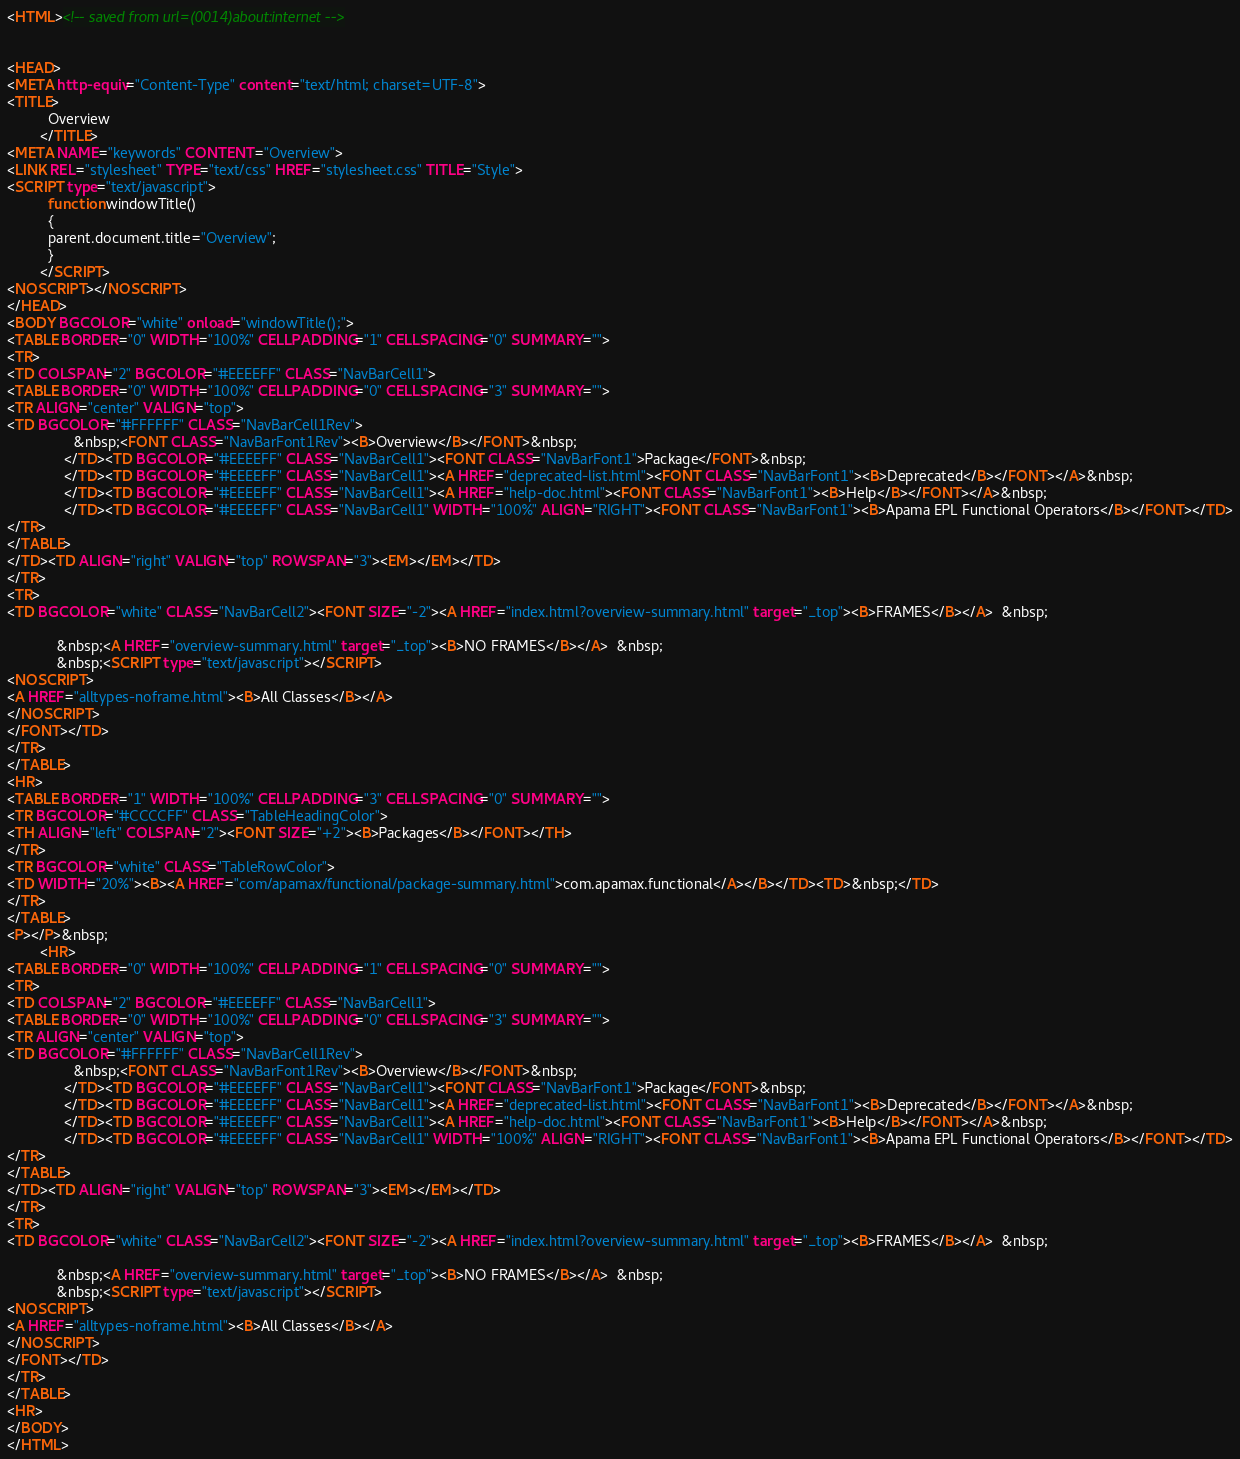Convert code to text. <code><loc_0><loc_0><loc_500><loc_500><_HTML_><HTML><!-- saved from url=(0014)about:internet -->


<HEAD>
<META http-equiv="Content-Type" content="text/html; charset=UTF-8">
<TITLE>
          Overview
        </TITLE>
<META NAME="keywords" CONTENT="Overview">
<LINK REL="stylesheet" TYPE="text/css" HREF="stylesheet.css" TITLE="Style">
<SCRIPT type="text/javascript">
          function windowTitle()
          {
          parent.document.title="Overview";
          }
        </SCRIPT>
<NOSCRIPT></NOSCRIPT>
</HEAD>
<BODY BGCOLOR="white" onload="windowTitle();">
<TABLE BORDER="0" WIDTH="100%" CELLPADDING="1" CELLSPACING="0" SUMMARY="">
<TR>
<TD COLSPAN="2" BGCOLOR="#EEEEFF" CLASS="NavBarCell1">
<TABLE BORDER="0" WIDTH="100%" CELLPADDING="0" CELLSPACING="3" SUMMARY="">
<TR ALIGN="center" VALIGN="top">
<TD BGCOLOR="#FFFFFF" CLASS="NavBarCell1Rev">
                &nbsp;<FONT CLASS="NavBarFont1Rev"><B>Overview</B></FONT>&nbsp;
              </TD><TD BGCOLOR="#EEEEFF" CLASS="NavBarCell1"><FONT CLASS="NavBarFont1">Package</FONT>&nbsp;
              </TD><TD BGCOLOR="#EEEEFF" CLASS="NavBarCell1"><A HREF="deprecated-list.html"><FONT CLASS="NavBarFont1"><B>Deprecated</B></FONT></A>&nbsp;
              </TD><TD BGCOLOR="#EEEEFF" CLASS="NavBarCell1"><A HREF="help-doc.html"><FONT CLASS="NavBarFont1"><B>Help</B></FONT></A>&nbsp;
              </TD><TD BGCOLOR="#EEEEFF" CLASS="NavBarCell1" WIDTH="100%" ALIGN="RIGHT"><FONT CLASS="NavBarFont1"><B>Apama EPL Functional Operators</B></FONT></TD>
</TR>
</TABLE>
</TD><TD ALIGN="right" VALIGN="top" ROWSPAN="3"><EM></EM></TD>
</TR>
<TR>
<TD BGCOLOR="white" CLASS="NavBarCell2"><FONT SIZE="-2"><A HREF="index.html?overview-summary.html" target="_top"><B>FRAMES</B></A>  &nbsp;

            &nbsp;<A HREF="overview-summary.html" target="_top"><B>NO FRAMES</B></A>  &nbsp;
            &nbsp;<SCRIPT type="text/javascript"></SCRIPT>
<NOSCRIPT>
<A HREF="alltypes-noframe.html"><B>All Classes</B></A>
</NOSCRIPT>
</FONT></TD>
</TR>
</TABLE>
<HR>
<TABLE BORDER="1" WIDTH="100%" CELLPADDING="3" CELLSPACING="0" SUMMARY="">
<TR BGCOLOR="#CCCCFF" CLASS="TableHeadingColor">
<TH ALIGN="left" COLSPAN="2"><FONT SIZE="+2"><B>Packages</B></FONT></TH>
</TR>
<TR BGCOLOR="white" CLASS="TableRowColor">
<TD WIDTH="20%"><B><A HREF="com/apamax/functional/package-summary.html">com.apamax.functional</A></B></TD><TD>&nbsp;</TD>
</TR>
</TABLE>
<P></P>&nbsp;
        <HR>
<TABLE BORDER="0" WIDTH="100%" CELLPADDING="1" CELLSPACING="0" SUMMARY="">
<TR>
<TD COLSPAN="2" BGCOLOR="#EEEEFF" CLASS="NavBarCell1">
<TABLE BORDER="0" WIDTH="100%" CELLPADDING="0" CELLSPACING="3" SUMMARY="">
<TR ALIGN="center" VALIGN="top">
<TD BGCOLOR="#FFFFFF" CLASS="NavBarCell1Rev">
                &nbsp;<FONT CLASS="NavBarFont1Rev"><B>Overview</B></FONT>&nbsp;
              </TD><TD BGCOLOR="#EEEEFF" CLASS="NavBarCell1"><FONT CLASS="NavBarFont1">Package</FONT>&nbsp;
              </TD><TD BGCOLOR="#EEEEFF" CLASS="NavBarCell1"><A HREF="deprecated-list.html"><FONT CLASS="NavBarFont1"><B>Deprecated</B></FONT></A>&nbsp;
              </TD><TD BGCOLOR="#EEEEFF" CLASS="NavBarCell1"><A HREF="help-doc.html"><FONT CLASS="NavBarFont1"><B>Help</B></FONT></A>&nbsp;
              </TD><TD BGCOLOR="#EEEEFF" CLASS="NavBarCell1" WIDTH="100%" ALIGN="RIGHT"><FONT CLASS="NavBarFont1"><B>Apama EPL Functional Operators</B></FONT></TD>
</TR>
</TABLE>
</TD><TD ALIGN="right" VALIGN="top" ROWSPAN="3"><EM></EM></TD>
</TR>
<TR>
<TD BGCOLOR="white" CLASS="NavBarCell2"><FONT SIZE="-2"><A HREF="index.html?overview-summary.html" target="_top"><B>FRAMES</B></A>  &nbsp;

            &nbsp;<A HREF="overview-summary.html" target="_top"><B>NO FRAMES</B></A>  &nbsp;
            &nbsp;<SCRIPT type="text/javascript"></SCRIPT>
<NOSCRIPT>
<A HREF="alltypes-noframe.html"><B>All Classes</B></A>
</NOSCRIPT>
</FONT></TD>
</TR>
</TABLE>
<HR>
</BODY>
</HTML>
</code> 